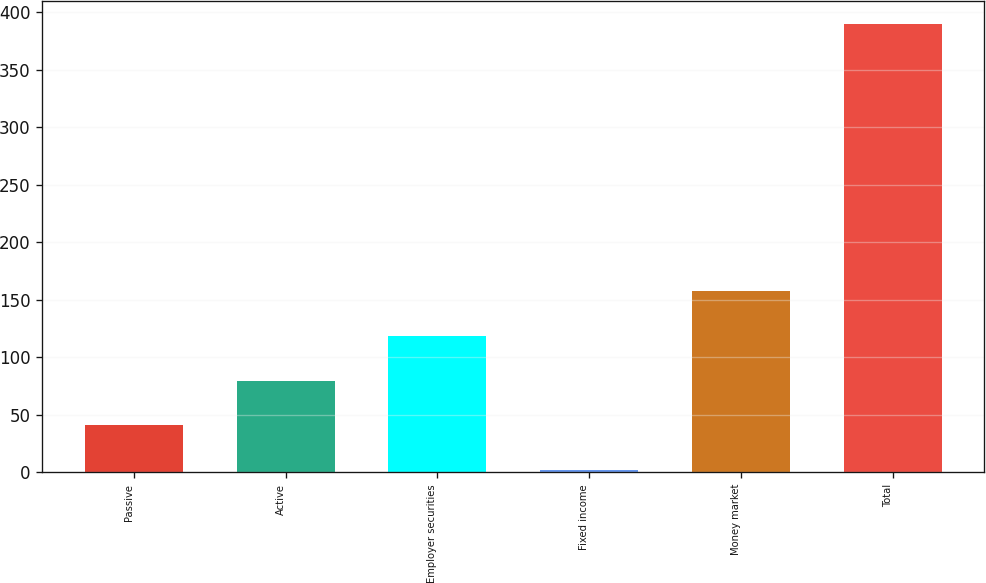Convert chart. <chart><loc_0><loc_0><loc_500><loc_500><bar_chart><fcel>Passive<fcel>Active<fcel>Employer securities<fcel>Fixed income<fcel>Money market<fcel>Total<nl><fcel>40.8<fcel>79.6<fcel>118.4<fcel>2<fcel>157.2<fcel>390<nl></chart> 